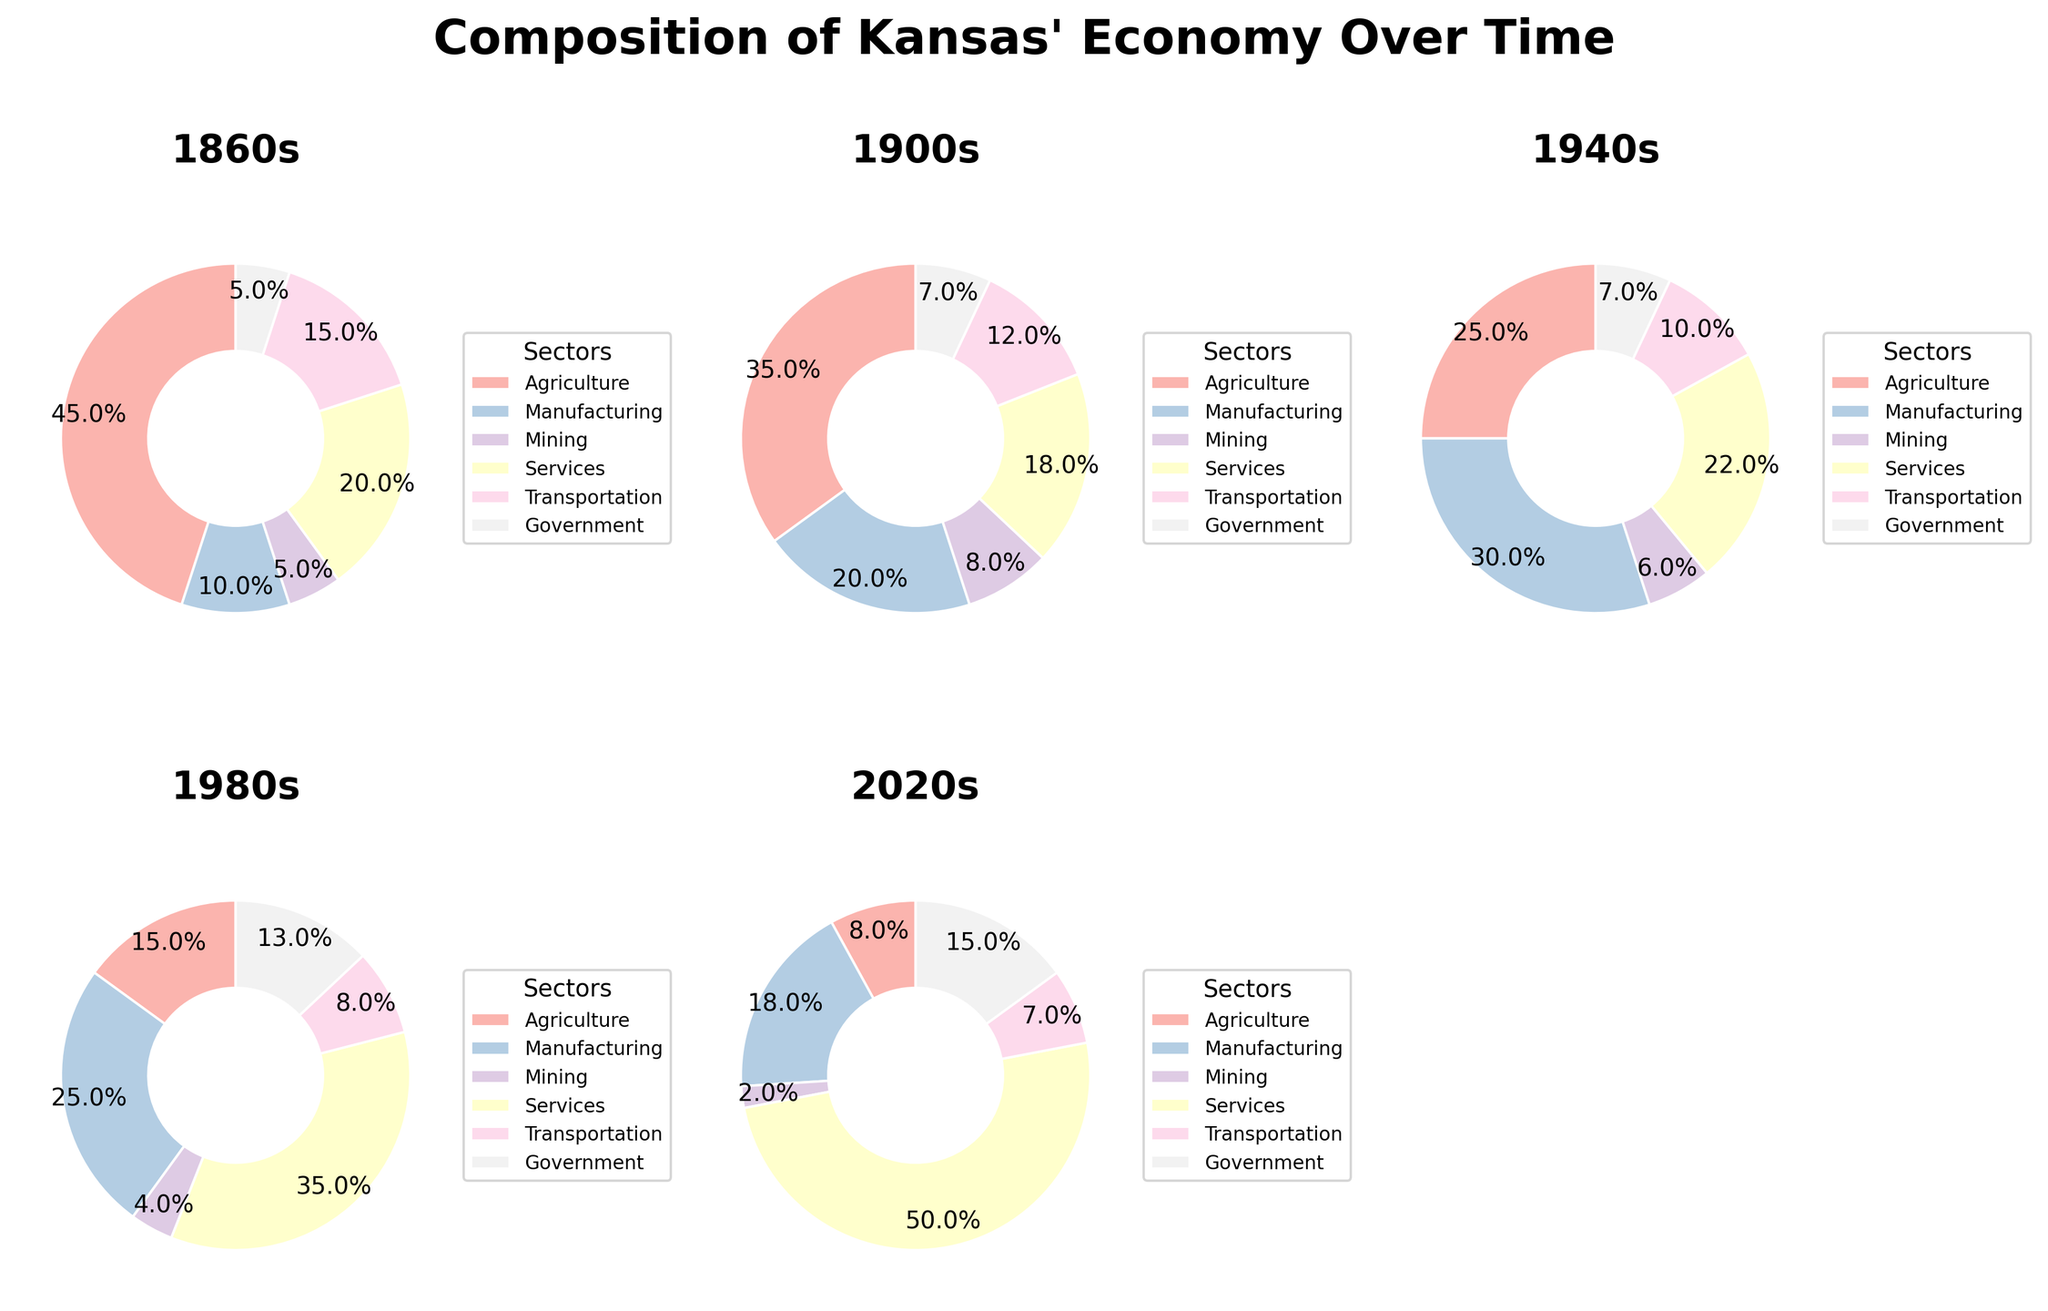What's the most significant sector in Kansas' economy in 1860s? In the 1860s pie chart, agriculture is the largest sector with a 45% share, as shown by the largest wedge.
Answer: Agriculture How did the share of the government sector change from the 1860s to the 2020s? In the 1860s, the government sector was at 5%, and by the 2020s, it increased to 15%. The change is 15% - 5% = 10%.
Answer: Increased by 10% Which period shows the highest percentage for the services sector? The services sector is at its highest in the 2020s with a 50% share, as the largest wedge in the 2020s pie chart indicates.
Answer: 2020s In which period was agriculture more dominant than manufacturing? Agriculture had a higher percentage than manufacturing in the 1860s (45% vs. 10%) and the 1900s (35% vs. 20%).
Answer: 1860s and 1900s Compare the shares of transportation in the 1860s and 2020s. The transportation sector had a 15% share in the 1860s and a 7% share in the 2020s. Comparing both, transportation decreased by 8%.
Answer: Decreased by 8% What is the total percentage share of all sectors excluding services in the 2020s? In the 2020s, the shares excluding services are agriculture (8%), manufacturing (18%), mining (2%), transportation (7%), and government (15%). Sum of these shares is 8% + 18% + 2% + 7% + 15% = 50%.
Answer: 50% How does the share of agriculture in the 1940s compare to the 1980s? The agricultural share in the 1940s was 25%, while in the 1980s it was 15%. Thus, agriculture's share decreased by 10%.
Answer: Decreased by 10% Identify the period with the smallest share of mining sector. The mining sector has the smallest share in the 2020s with just 2%, which is the smallest wedge in that period's pie chart.
Answer: 2020s Which two periods have equal shares for the government sector? The government sector has the same share of 7% in both the 1900s and 1940s, as indicated by similar-sized wedges in these periods' pie charts.
Answer: 1900s and 1940s Determine the overall trend for the services sector from the 1860s to the 2020s. The services sector shows an increasing trend: 20% (1860s), 18% (1900s), 22% (1940s), 35% (1980s), and 50% (2020s).
Answer: Increasing trend 